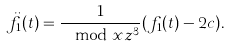<formula> <loc_0><loc_0><loc_500><loc_500>\ddot { f } _ { 1 } ( t ) = \frac { 1 } { \mod x z ^ { 3 } } ( f _ { 1 } ( t ) - 2 c ) .</formula> 